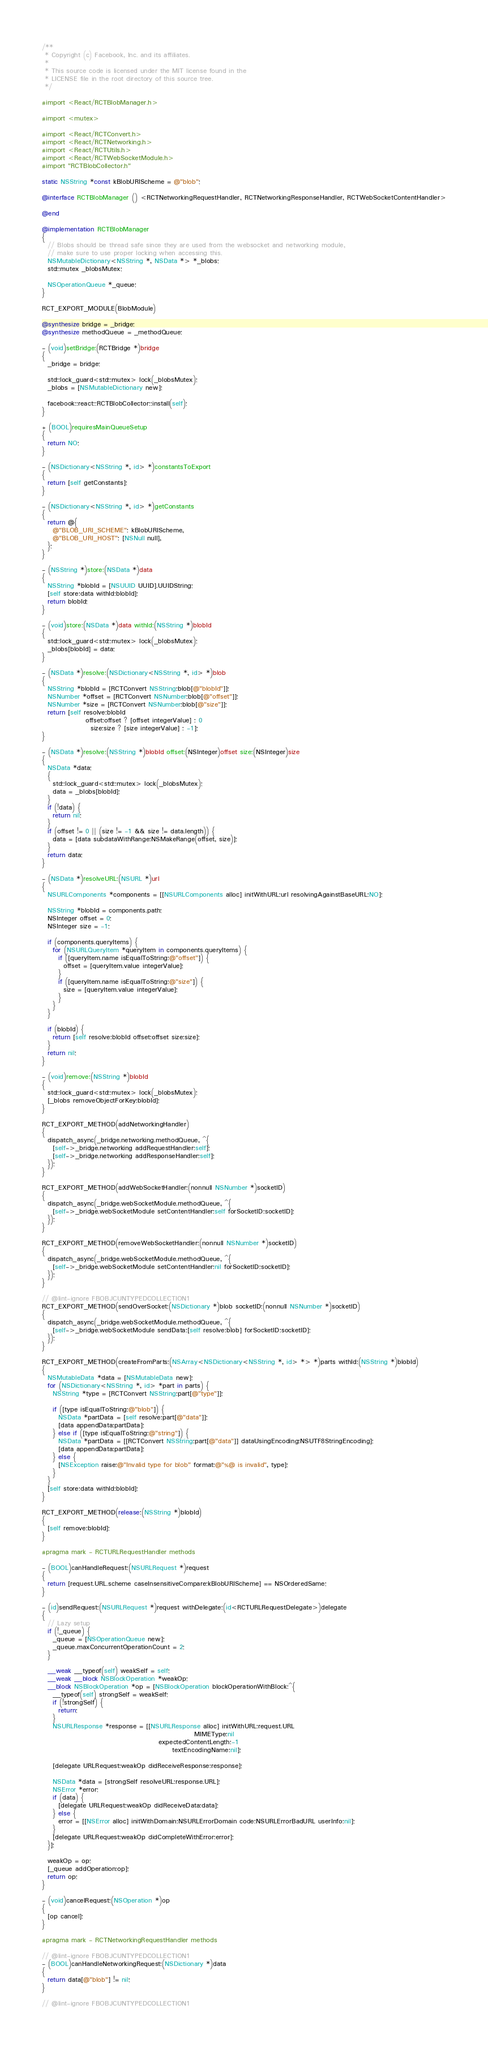<code> <loc_0><loc_0><loc_500><loc_500><_ObjectiveC_>/**
 * Copyright (c) Facebook, Inc. and its affiliates.
 *
 * This source code is licensed under the MIT license found in the
 * LICENSE file in the root directory of this source tree.
 */

#import <React/RCTBlobManager.h>

#import <mutex>

#import <React/RCTConvert.h>
#import <React/RCTNetworking.h>
#import <React/RCTUtils.h>
#import <React/RCTWebSocketModule.h>
#import "RCTBlobCollector.h"

static NSString *const kBlobURIScheme = @"blob";

@interface RCTBlobManager () <RCTNetworkingRequestHandler, RCTNetworkingResponseHandler, RCTWebSocketContentHandler>

@end

@implementation RCTBlobManager
{
  // Blobs should be thread safe since they are used from the websocket and networking module,
  // make sure to use proper locking when accessing this.
  NSMutableDictionary<NSString *, NSData *> *_blobs;
  std::mutex _blobsMutex;

  NSOperationQueue *_queue;
}

RCT_EXPORT_MODULE(BlobModule)

@synthesize bridge = _bridge;
@synthesize methodQueue = _methodQueue;

- (void)setBridge:(RCTBridge *)bridge
{
  _bridge = bridge;

  std::lock_guard<std::mutex> lock(_blobsMutex);
  _blobs = [NSMutableDictionary new];

  facebook::react::RCTBlobCollector::install(self);
}

+ (BOOL)requiresMainQueueSetup
{
  return NO;
}

- (NSDictionary<NSString *, id> *)constantsToExport
{
  return [self getConstants];
}

- (NSDictionary<NSString *, id> *)getConstants
{
  return @{
    @"BLOB_URI_SCHEME": kBlobURIScheme,
    @"BLOB_URI_HOST": [NSNull null],
  };
}

- (NSString *)store:(NSData *)data
{
  NSString *blobId = [NSUUID UUID].UUIDString;
  [self store:data withId:blobId];
  return blobId;
}

- (void)store:(NSData *)data withId:(NSString *)blobId
{
  std::lock_guard<std::mutex> lock(_blobsMutex);
  _blobs[blobId] = data;
}

- (NSData *)resolve:(NSDictionary<NSString *, id> *)blob
{
  NSString *blobId = [RCTConvert NSString:blob[@"blobId"]];
  NSNumber *offset = [RCTConvert NSNumber:blob[@"offset"]];
  NSNumber *size = [RCTConvert NSNumber:blob[@"size"]];
  return [self resolve:blobId
                offset:offset ? [offset integerValue] : 0
                  size:size ? [size integerValue] : -1];
}

- (NSData *)resolve:(NSString *)blobId offset:(NSInteger)offset size:(NSInteger)size
{
  NSData *data;
  {
    std::lock_guard<std::mutex> lock(_blobsMutex);
    data = _blobs[blobId];
  }
  if (!data) {
    return nil;
  }
  if (offset != 0 || (size != -1 && size != data.length)) {
    data = [data subdataWithRange:NSMakeRange(offset, size)];
  }
  return data;
}

- (NSData *)resolveURL:(NSURL *)url
{
  NSURLComponents *components = [[NSURLComponents alloc] initWithURL:url resolvingAgainstBaseURL:NO];

  NSString *blobId = components.path;
  NSInteger offset = 0;
  NSInteger size = -1;

  if (components.queryItems) {
    for (NSURLQueryItem *queryItem in components.queryItems) {
      if ([queryItem.name isEqualToString:@"offset"]) {
        offset = [queryItem.value integerValue];
      }
      if ([queryItem.name isEqualToString:@"size"]) {
        size = [queryItem.value integerValue];
      }
    }
  }

  if (blobId) {
    return [self resolve:blobId offset:offset size:size];
  }
  return nil;
}

- (void)remove:(NSString *)blobId
{
  std::lock_guard<std::mutex> lock(_blobsMutex);
  [_blobs removeObjectForKey:blobId];
}

RCT_EXPORT_METHOD(addNetworkingHandler)
{
  dispatch_async(_bridge.networking.methodQueue, ^{
    [self->_bridge.networking addRequestHandler:self];
    [self->_bridge.networking addResponseHandler:self];
  });
}

RCT_EXPORT_METHOD(addWebSocketHandler:(nonnull NSNumber *)socketID)
{
  dispatch_async(_bridge.webSocketModule.methodQueue, ^{
    [self->_bridge.webSocketModule setContentHandler:self forSocketID:socketID];
  });
}

RCT_EXPORT_METHOD(removeWebSocketHandler:(nonnull NSNumber *)socketID)
{
  dispatch_async(_bridge.webSocketModule.methodQueue, ^{
    [self->_bridge.webSocketModule setContentHandler:nil forSocketID:socketID];
  });
}

// @lint-ignore FBOBJCUNTYPEDCOLLECTION1
RCT_EXPORT_METHOD(sendOverSocket:(NSDictionary *)blob socketID:(nonnull NSNumber *)socketID)
{
  dispatch_async(_bridge.webSocketModule.methodQueue, ^{
    [self->_bridge.webSocketModule sendData:[self resolve:blob] forSocketID:socketID];
  });
}

RCT_EXPORT_METHOD(createFromParts:(NSArray<NSDictionary<NSString *, id> *> *)parts withId:(NSString *)blobId)
{
  NSMutableData *data = [NSMutableData new];
  for (NSDictionary<NSString *, id> *part in parts) {
    NSString *type = [RCTConvert NSString:part[@"type"]];

    if ([type isEqualToString:@"blob"]) {
      NSData *partData = [self resolve:part[@"data"]];
      [data appendData:partData];
    } else if ([type isEqualToString:@"string"]) {
      NSData *partData = [[RCTConvert NSString:part[@"data"]] dataUsingEncoding:NSUTF8StringEncoding];
      [data appendData:partData];
    } else {
      [NSException raise:@"Invalid type for blob" format:@"%@ is invalid", type];
    }
  }
  [self store:data withId:blobId];
}

RCT_EXPORT_METHOD(release:(NSString *)blobId)
{
  [self remove:blobId];
}

#pragma mark - RCTURLRequestHandler methods

- (BOOL)canHandleRequest:(NSURLRequest *)request
{
  return [request.URL.scheme caseInsensitiveCompare:kBlobURIScheme] == NSOrderedSame;
}

- (id)sendRequest:(NSURLRequest *)request withDelegate:(id<RCTURLRequestDelegate>)delegate
{
  // Lazy setup
  if (!_queue) {
    _queue = [NSOperationQueue new];
    _queue.maxConcurrentOperationCount = 2;
  }

  __weak __typeof(self) weakSelf = self;
  __weak __block NSBlockOperation *weakOp;
  __block NSBlockOperation *op = [NSBlockOperation blockOperationWithBlock:^{
    __typeof(self) strongSelf = weakSelf;
    if (!strongSelf) {
      return;
    }
    NSURLResponse *response = [[NSURLResponse alloc] initWithURL:request.URL
                                                        MIMEType:nil
                                           expectedContentLength:-1
                                                textEncodingName:nil];

    [delegate URLRequest:weakOp didReceiveResponse:response];

    NSData *data = [strongSelf resolveURL:response.URL];
    NSError *error;
    if (data) {
      [delegate URLRequest:weakOp didReceiveData:data];
    } else {
      error = [[NSError alloc] initWithDomain:NSURLErrorDomain code:NSURLErrorBadURL userInfo:nil];
    }
    [delegate URLRequest:weakOp didCompleteWithError:error];
  }];

  weakOp = op;
  [_queue addOperation:op];
  return op;
}

- (void)cancelRequest:(NSOperation *)op
{
  [op cancel];
}

#pragma mark - RCTNetworkingRequestHandler methods

// @lint-ignore FBOBJCUNTYPEDCOLLECTION1
- (BOOL)canHandleNetworkingRequest:(NSDictionary *)data
{
  return data[@"blob"] != nil;
}

// @lint-ignore FBOBJCUNTYPEDCOLLECTION1</code> 